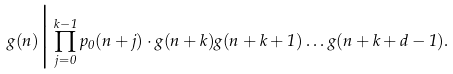<formula> <loc_0><loc_0><loc_500><loc_500>g ( n ) \Big | \prod _ { j = 0 } ^ { k - 1 } p _ { 0 } ( n + j ) \cdot g ( n + k ) g ( n + k + 1 ) \dots g ( n + k + d - 1 ) .</formula> 